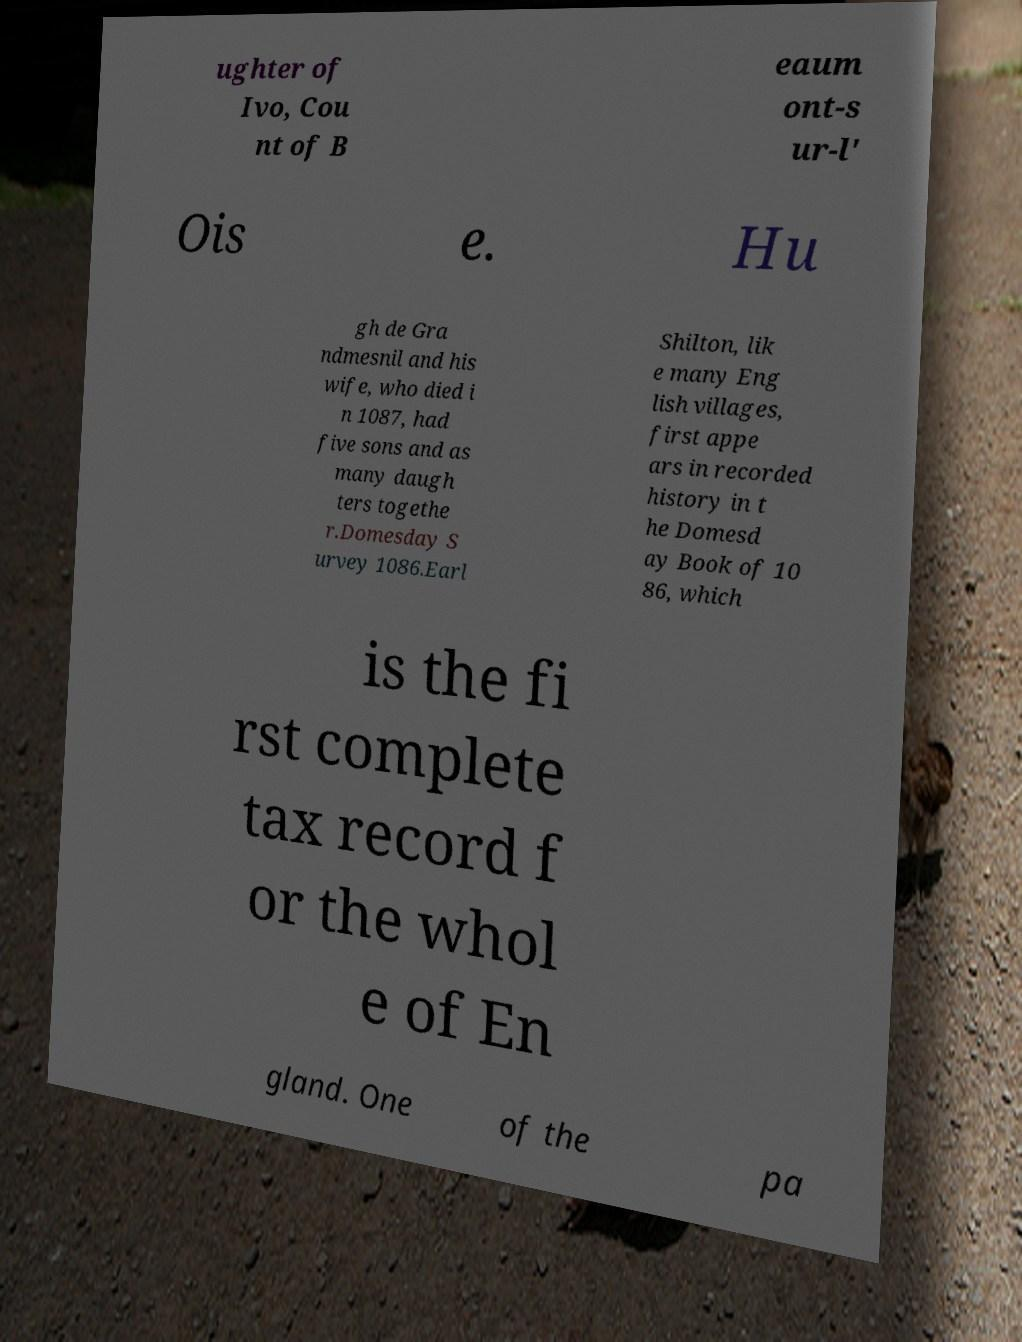There's text embedded in this image that I need extracted. Can you transcribe it verbatim? ughter of Ivo, Cou nt of B eaum ont-s ur-l' Ois e. Hu gh de Gra ndmesnil and his wife, who died i n 1087, had five sons and as many daugh ters togethe r.Domesday S urvey 1086.Earl Shilton, lik e many Eng lish villages, first appe ars in recorded history in t he Domesd ay Book of 10 86, which is the fi rst complete tax record f or the whol e of En gland. One of the pa 